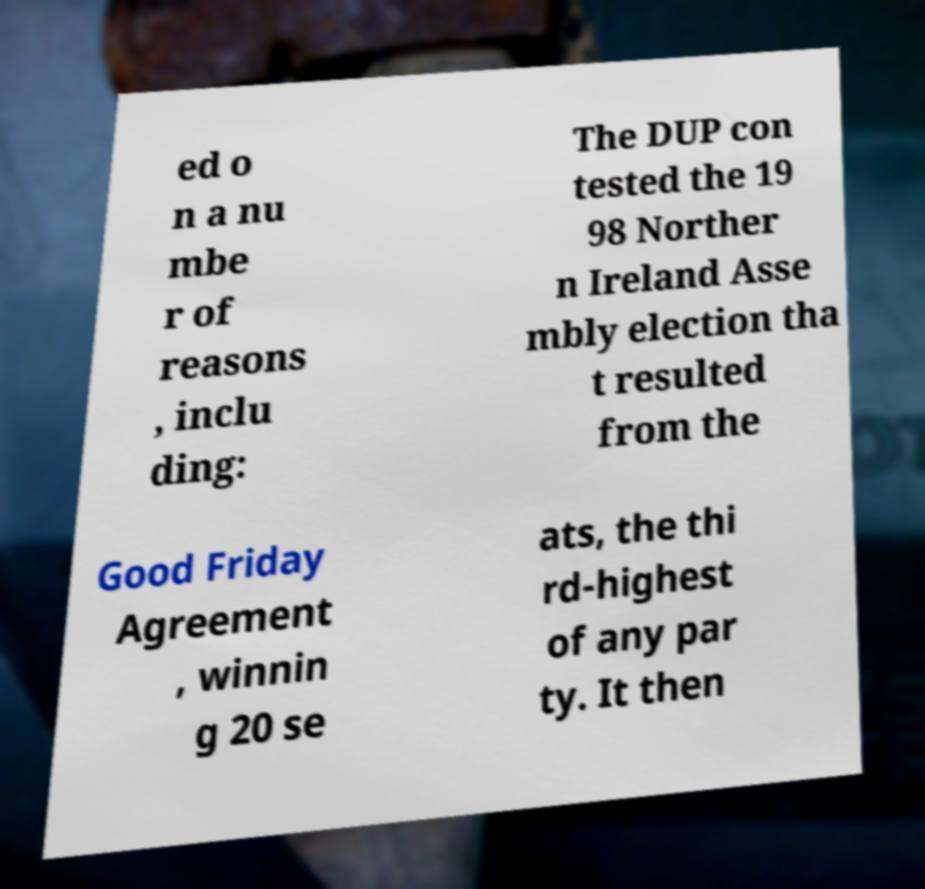I need the written content from this picture converted into text. Can you do that? ed o n a nu mbe r of reasons , inclu ding: The DUP con tested the 19 98 Norther n Ireland Asse mbly election tha t resulted from the Good Friday Agreement , winnin g 20 se ats, the thi rd-highest of any par ty. It then 